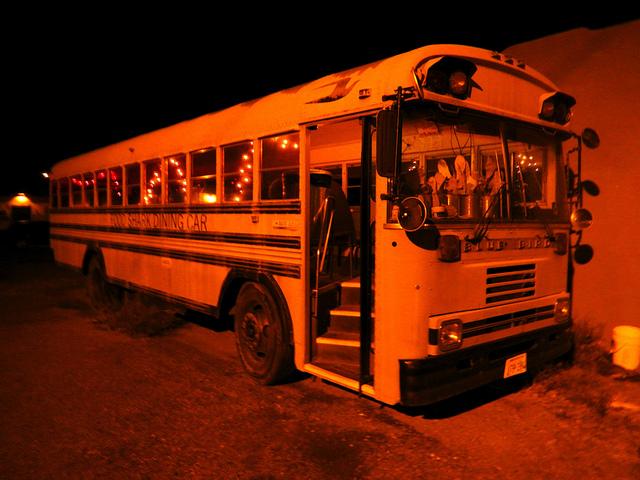Are there lights behind the photographer?
Write a very short answer. Yes. What was the original use of this vehicle?
Write a very short answer. School bus. What does the writing on the side of the bus say?
Concise answer only. Food shark dining car. 